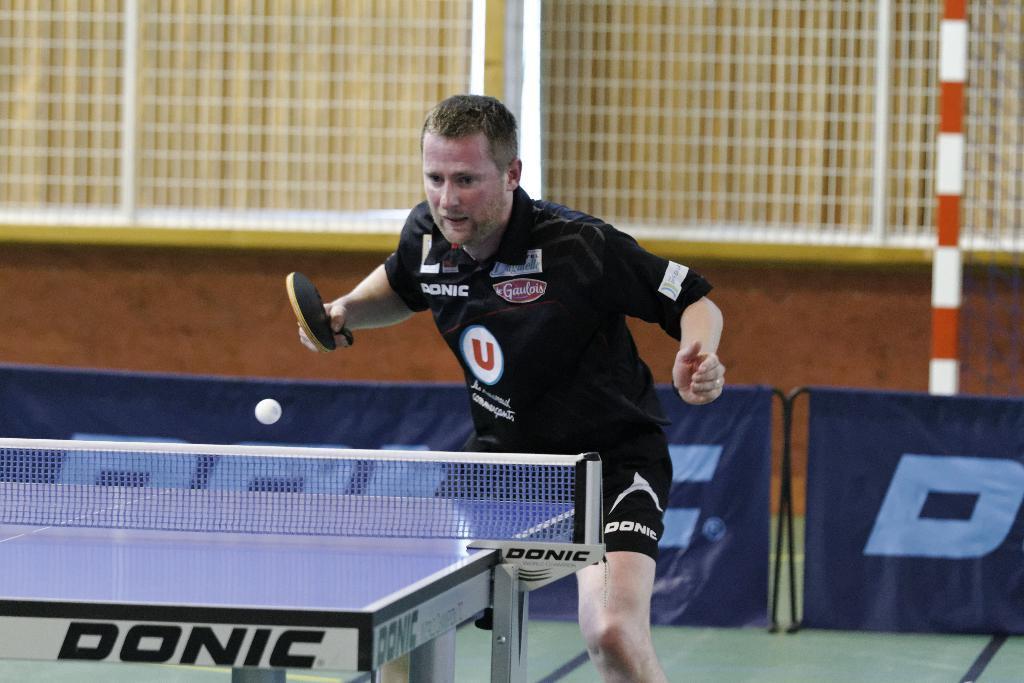How would you summarize this image in a sentence or two? Here we can see a man playing a table tennis by holding a bat in his hand. 